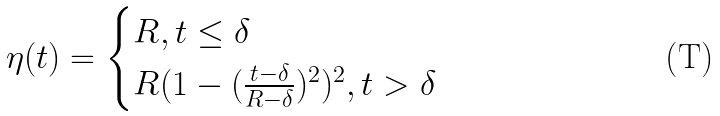Convert formula to latex. <formula><loc_0><loc_0><loc_500><loc_500>\eta ( t ) = \begin{cases} R , t \leq \delta \\ R ( 1 - ( \frac { t - \delta } { R - \delta } ) ^ { 2 } ) ^ { 2 } , t > \delta \end{cases}</formula> 